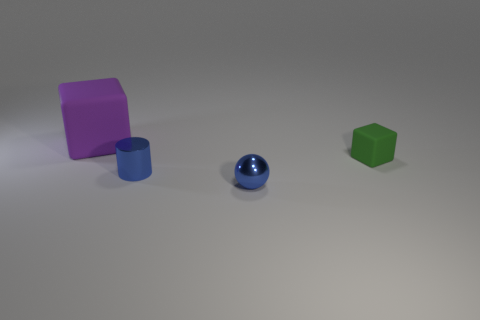Imagine these objects are part of a game. What could be the rules or objective? In a hypothetical game, these objects could be used in a sorting challenge where the player needs to group items by shape or color within a time limit. Alternatively, they could form part of a puzzle where the player must stack the objects to achieve a specified height without tipping them over. 